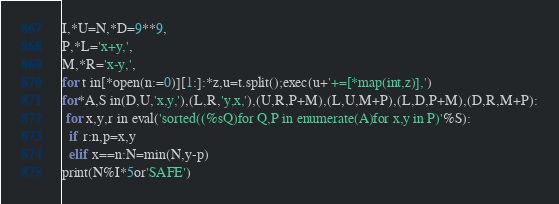Convert code to text. <code><loc_0><loc_0><loc_500><loc_500><_Python_>I,*U=N,*D=9**9,
P,*L='x+y,',
M,*R='x-y,',
for t in[*open(n:=0)][1:]:*z,u=t.split();exec(u+'+=[*map(int,z)],')
for*A,S in(D,U,'x,y,'),(L,R,'y,x,'),(U,R,P+M),(L,U,M+P),(L,D,P+M),(D,R,M+P):
 for x,y,r in eval('sorted((%sQ)for Q,P in enumerate(A)for x,y in P)'%S):
  if r:n,p=x,y
  elif x==n:N=min(N,y-p)
print(N%I*5or'SAFE')</code> 